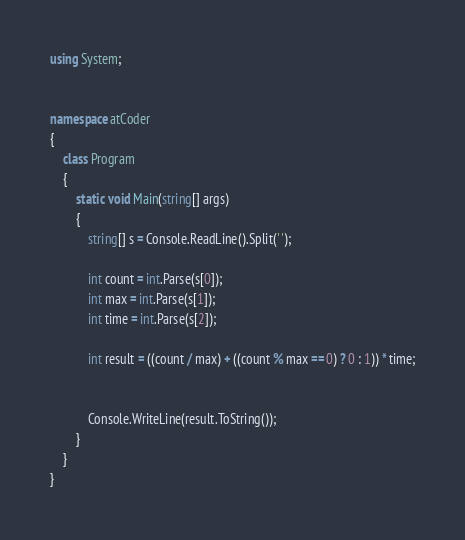<code> <loc_0><loc_0><loc_500><loc_500><_C#_>using System;


namespace atCoder
{
    class Program
    {
        static void Main(string[] args)
        {
            string[] s = Console.ReadLine().Split(' ');

            int count = int.Parse(s[0]);
            int max = int.Parse(s[1]);
            int time = int.Parse(s[2]);

            int result = ((count / max) + ((count % max == 0) ? 0 : 1)) * time;


            Console.WriteLine(result.ToString());
        }
    }
}</code> 